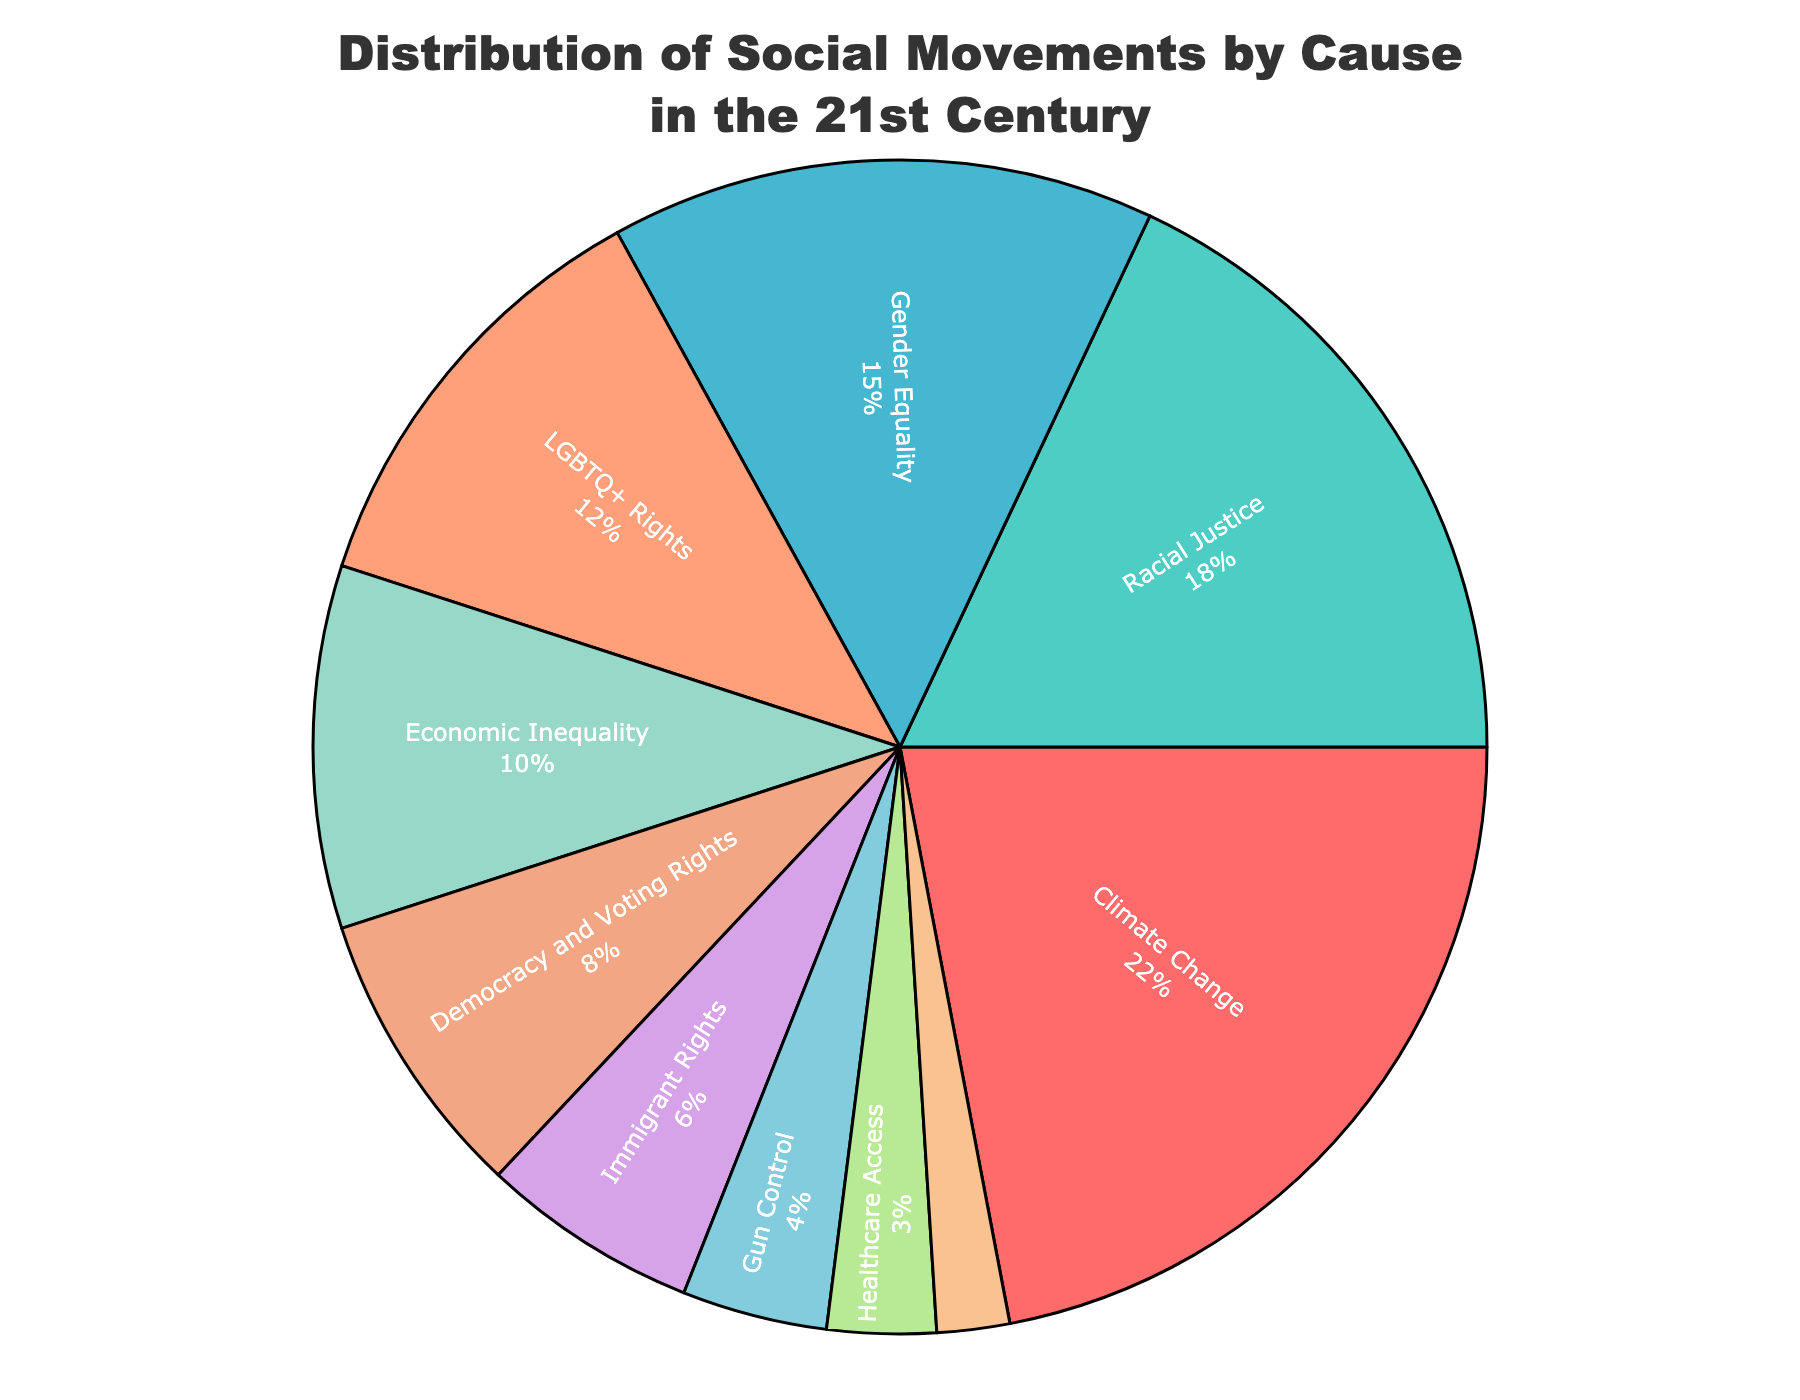What is the largest cause of social movements in this pie chart? The pie chart shows that Climate Change accounts for the largest percentage, which is 22%.
Answer: Climate Change What is the combined percentage of social movements related to Racial Justice and Gender Equality? The percentages for Racial Justice and Gender Equality are 18% and 15%, respectively. So, the combined percentage is 18% + 15% = 33%.
Answer: 33% Is the percentage of social movements focusing on LGBTQ+ Rights greater than those focusing on Economic Inequality? The percentage for LGBTQ+ Rights is 12%, whereas for Economic Inequality it is 10%. Since 12% > 10%, LGBTQ+ Rights have a higher percentage.
Answer: Yes What cause has the smallest percentage in the pie chart? The pie chart shows that Education Reform has the smallest percentage, which is 2%.
Answer: Education Reform Which causes of social movements have percentages less than 10%? The causes with percentages less than 10% are Democracy and Voting Rights (8%), Immigrant Rights (6%), Gun Control (4%), Healthcare Access (3%), and Education Reform (2%).
Answer: Democracy and Voting Rights, Immigrant Rights, Gun Control, Healthcare Access, Education Reform How much more percentage does Climate Change have than Immigrant Rights? Climate Change has 22%, and Immigrant Rights have 6%. The difference is 22% - 6% = 16%.
Answer: 16% What is the total percentage of the top three causes in the pie chart? The top three causes are Climate Change (22%), Racial Justice (18%), and Gender Equality (15%). The total percentage is 22% + 18% + 15% = 55%.
Answer: 55% If we combine Healthcare Access and Gun Control, does the total surpass the percentage of LGBTQ+ Rights? Healthcare Access is 3%, and Gun Control is 4%. Combined, they are 3% + 4% = 7%. Since 7% is less than LGBTQ+ Rights’ 12%, the total does not surpass.
Answer: No What visual attribute helps in distinguishing the different causes in the pie chart? The pie chart uses different colors for each cause, along with labels and percentages, to help distinguish them.
Answer: Different colors Which two causes together still account for less than 10% of the social movements? Gun Control (4%) and Healthcare Access (3%) together account for 4% + 3% = 7%, which is less than 10%.
Answer: Gun Control and Healthcare Access 